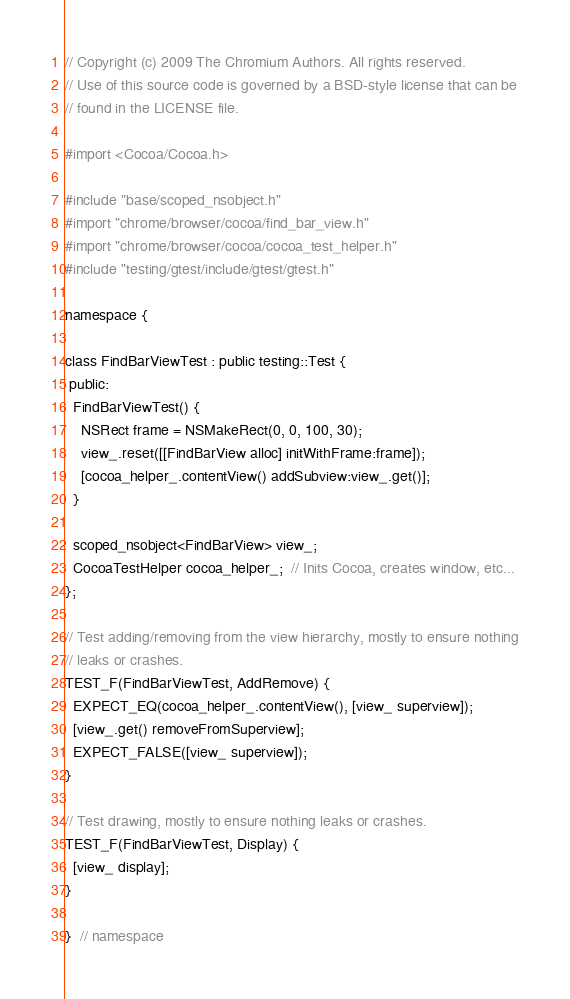<code> <loc_0><loc_0><loc_500><loc_500><_ObjectiveC_>// Copyright (c) 2009 The Chromium Authors. All rights reserved.
// Use of this source code is governed by a BSD-style license that can be
// found in the LICENSE file.

#import <Cocoa/Cocoa.h>

#include "base/scoped_nsobject.h"
#import "chrome/browser/cocoa/find_bar_view.h"
#import "chrome/browser/cocoa/cocoa_test_helper.h"
#include "testing/gtest/include/gtest/gtest.h"

namespace {

class FindBarViewTest : public testing::Test {
 public:
  FindBarViewTest() {
    NSRect frame = NSMakeRect(0, 0, 100, 30);
    view_.reset([[FindBarView alloc] initWithFrame:frame]);
    [cocoa_helper_.contentView() addSubview:view_.get()];
  }

  scoped_nsobject<FindBarView> view_;
  CocoaTestHelper cocoa_helper_;  // Inits Cocoa, creates window, etc...
};

// Test adding/removing from the view hierarchy, mostly to ensure nothing
// leaks or crashes.
TEST_F(FindBarViewTest, AddRemove) {
  EXPECT_EQ(cocoa_helper_.contentView(), [view_ superview]);
  [view_.get() removeFromSuperview];
  EXPECT_FALSE([view_ superview]);
}

// Test drawing, mostly to ensure nothing leaks or crashes.
TEST_F(FindBarViewTest, Display) {
  [view_ display];
}

}  // namespace
</code> 